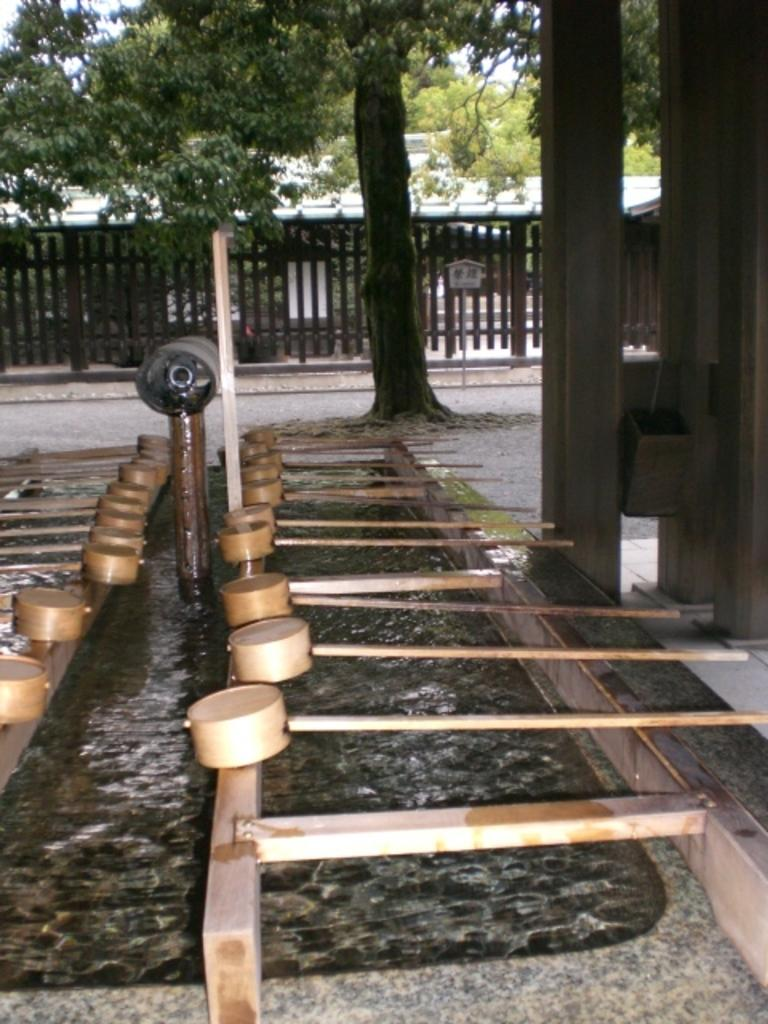What type of barrier can be seen in the image? There is a fence in the image. What type of natural elements are present in the image? There are trees in the image. What type of material is used for the objects on the ground? The wooden objects on the ground are made of wood. What other objects can be seen on the ground? There are other objects on the ground besides the wooden ones. Can you see any grass growing near the fence in the image? There is no mention of grass in the provided facts, so it cannot be confirmed whether grass is present or not. Is there a volcano visible in the image? There is no mention of a volcano in the provided facts, so it cannot be confirmed whether a volcano is present or not. 